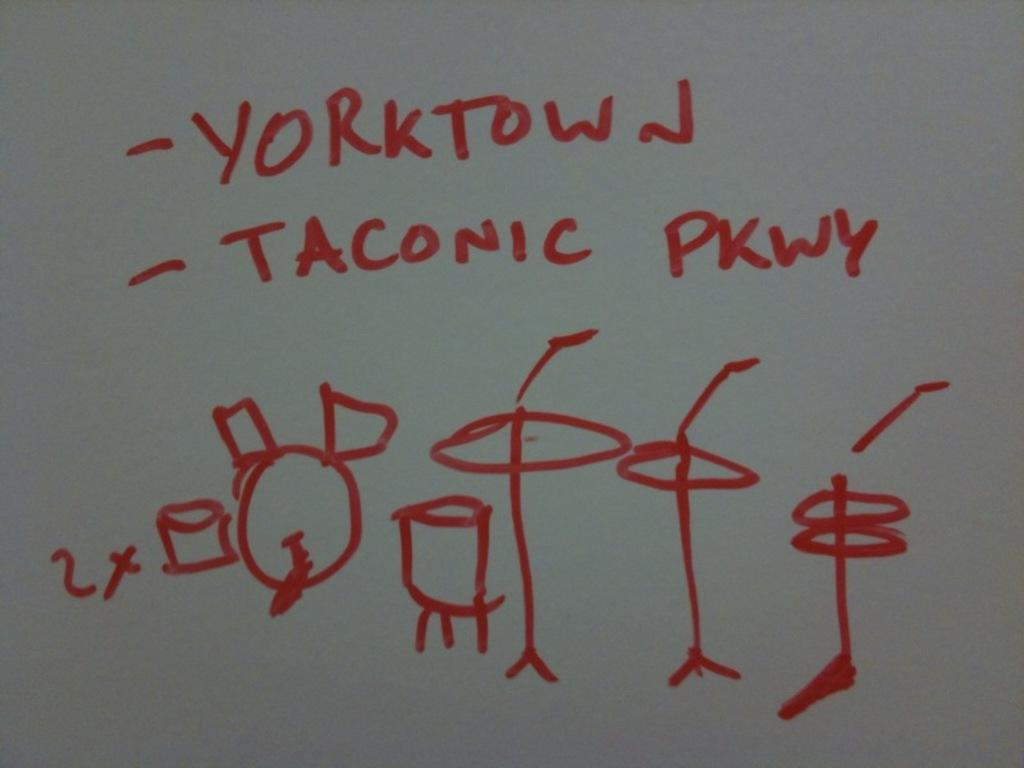Provide a one-sentence caption for the provided image. A stick figure drawing in red marker says "yorktown". 